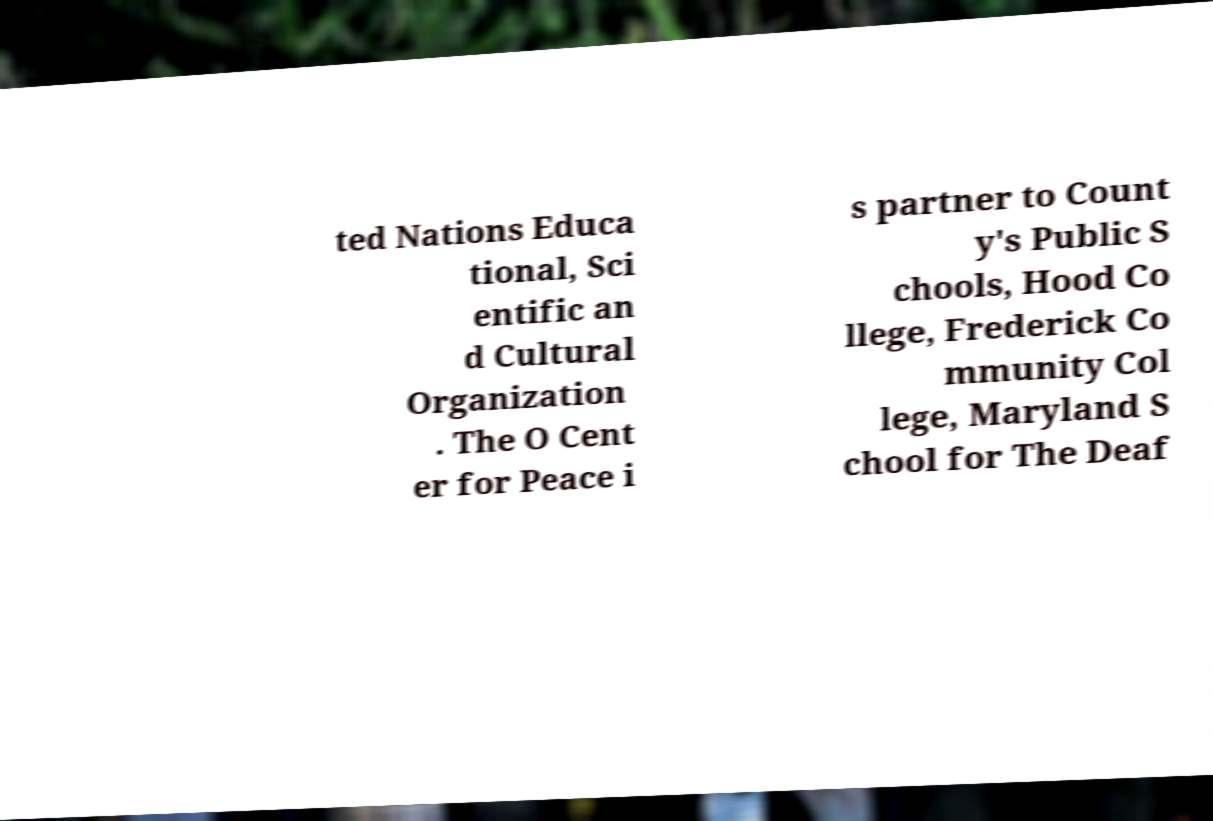Can you accurately transcribe the text from the provided image for me? ted Nations Educa tional, Sci entific an d Cultural Organization . The O Cent er for Peace i s partner to Count y's Public S chools, Hood Co llege, Frederick Co mmunity Col lege, Maryland S chool for The Deaf 